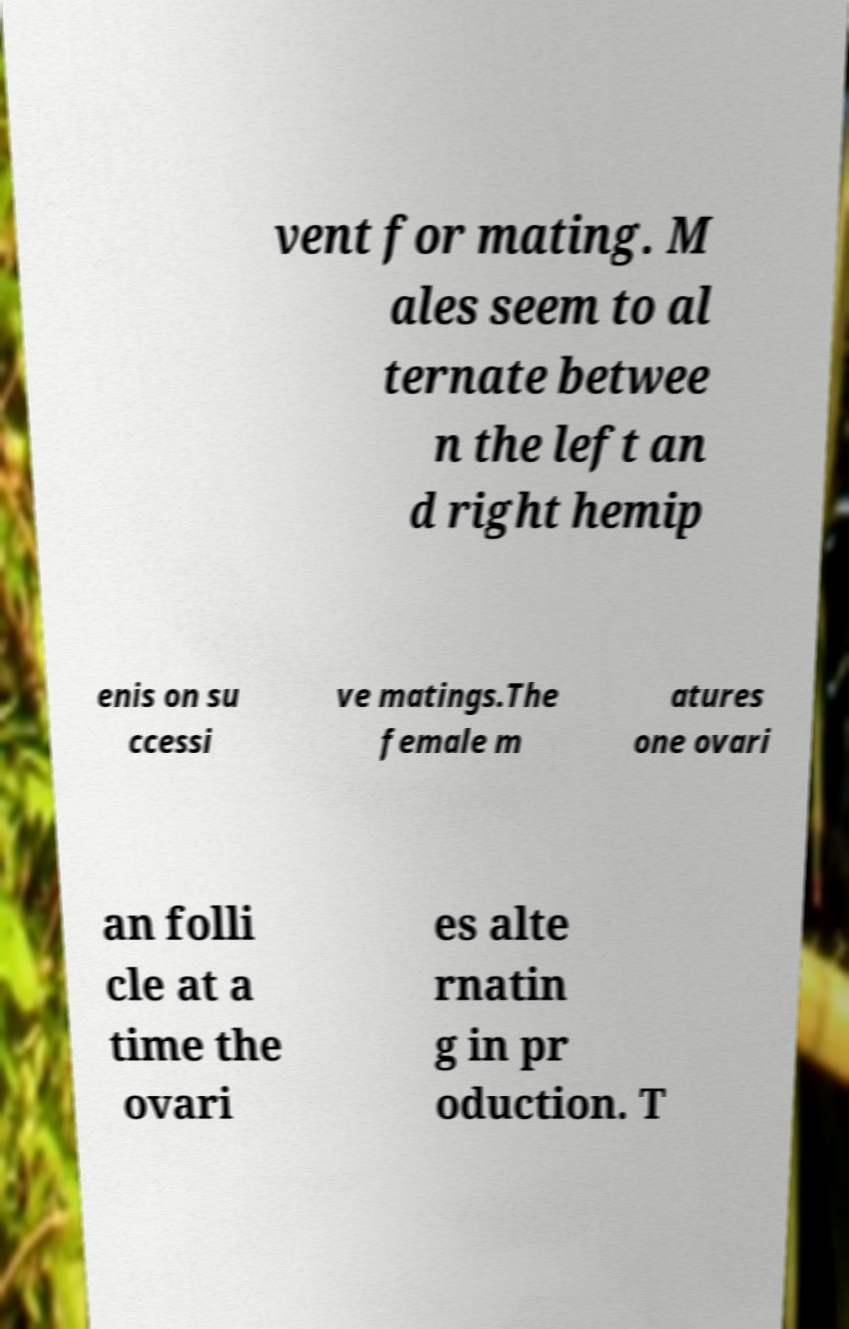What messages or text are displayed in this image? I need them in a readable, typed format. vent for mating. M ales seem to al ternate betwee n the left an d right hemip enis on su ccessi ve matings.The female m atures one ovari an folli cle at a time the ovari es alte rnatin g in pr oduction. T 